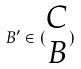Convert formula to latex. <formula><loc_0><loc_0><loc_500><loc_500>B ^ { \prime } \in ( \begin{matrix} C \\ B \end{matrix} )</formula> 